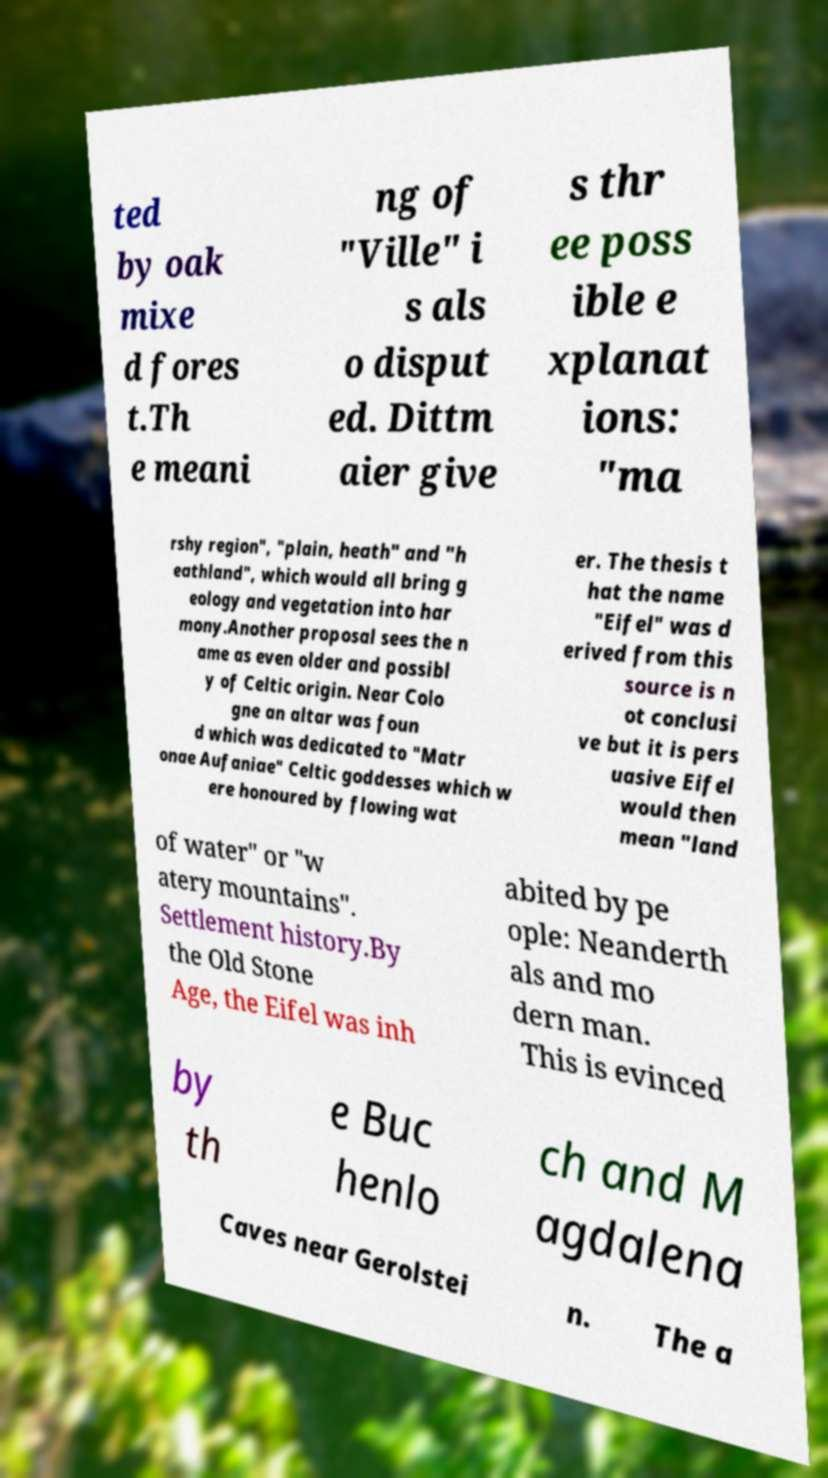Please read and relay the text visible in this image. What does it say? ted by oak mixe d fores t.Th e meani ng of "Ville" i s als o disput ed. Dittm aier give s thr ee poss ible e xplanat ions: "ma rshy region", "plain, heath" and "h eathland", which would all bring g eology and vegetation into har mony.Another proposal sees the n ame as even older and possibl y of Celtic origin. Near Colo gne an altar was foun d which was dedicated to "Matr onae Aufaniae" Celtic goddesses which w ere honoured by flowing wat er. The thesis t hat the name "Eifel" was d erived from this source is n ot conclusi ve but it is pers uasive Eifel would then mean "land of water" or "w atery mountains". Settlement history.By the Old Stone Age, the Eifel was inh abited by pe ople: Neanderth als and mo dern man. This is evinced by th e Buc henlo ch and M agdalena Caves near Gerolstei n. The a 